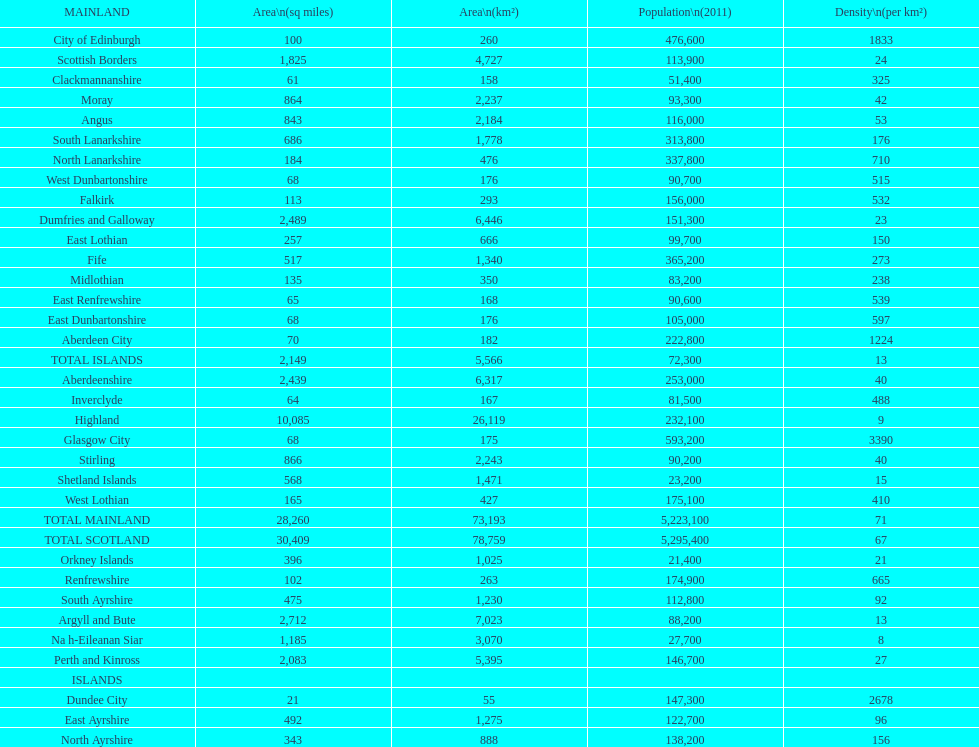What number of mainlands have populations under 100,000? 9. 